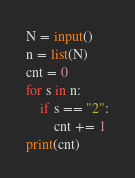<code> <loc_0><loc_0><loc_500><loc_500><_Python_>N = input()
n = list(N)
cnt = 0
for s in n:
    if s == "2":
        cnt += 1
print(cnt)
</code> 